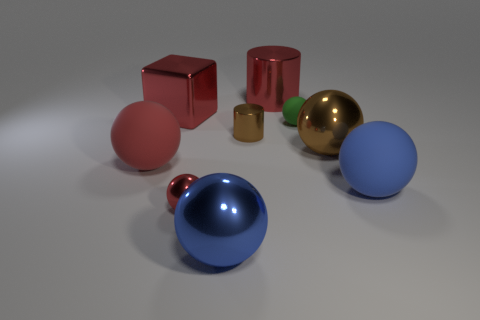There is a large rubber thing on the right side of the shiny sphere that is on the right side of the large blue metal sphere; what is its shape?
Offer a terse response. Sphere. Is the number of rubber objects that are to the left of the blue metallic sphere the same as the number of tiny yellow things?
Make the answer very short. No. What is the material of the green ball that is right of the ball that is on the left side of the shiny object on the left side of the tiny red sphere?
Keep it short and to the point. Rubber. Is there another shiny thing of the same size as the blue metal object?
Keep it short and to the point. Yes. The small green matte object has what shape?
Offer a terse response. Sphere. How many spheres are matte objects or big blue metal objects?
Make the answer very short. 4. Is the number of small red shiny balls behind the large red block the same as the number of red metal spheres that are in front of the tiny red shiny thing?
Ensure brevity in your answer.  Yes. There is a blue matte sphere that is to the right of the red rubber ball that is behind the large blue matte ball; what number of cylinders are in front of it?
Offer a very short reply. 0. There is a large metallic thing that is the same color as the large shiny block; what is its shape?
Offer a terse response. Cylinder. Is the color of the large metal cylinder the same as the tiny object to the right of the small brown object?
Your answer should be compact. No. 